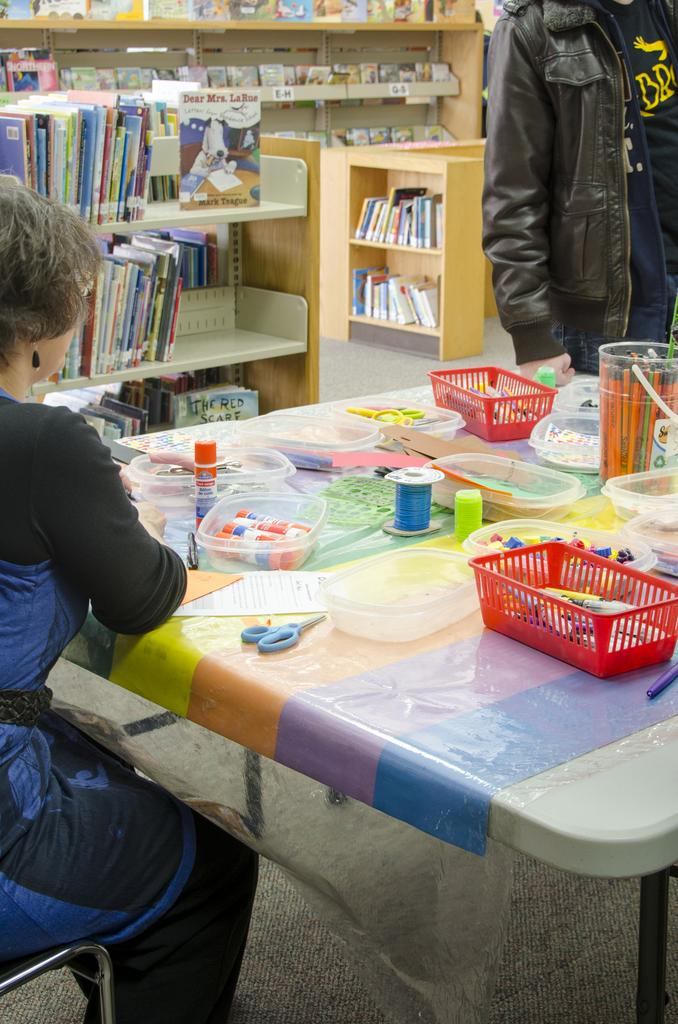What is the woman in the image doing? The woman is sitting in the image. What objects are on the table in the image? There are boxes, a scissor, paper, and thread on the table in the image. Can you describe the person standing in the background? There is a person standing in the background, but no specific details are provided about their appearance or actions. What can be seen on the rack in the background? There are books on a rack in the background. What type of grape is the woman holding in the image? There is no grape present in the image; the woman is sitting and there are no fruits mentioned in the facts. 